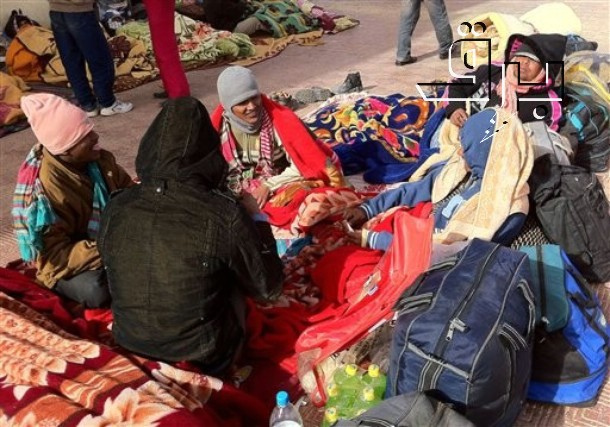What creative story could explain the scene in this image? In a small hidden corner of a bustling metropolis, these six individuals are part of a secret club known as the 'Winter Wanderers.' Every winter, they roam from city to city, bringing warmth and cheer to those in need. This year, they've set up camp here, covering the ground with their magical blankets that provide not only physical warmth but also a sense of joy and community. Each item they carry holds a story – the red bag contains an endless supply of hot cocoa, while the bottles are filled with an elixir that can rejuvenate the spirit. Their mission is to remind everyone they encounter of the power of togetherness and the magic that can be found within human connections, no matter the external cold. 